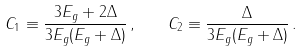<formula> <loc_0><loc_0><loc_500><loc_500>C _ { 1 } \equiv \frac { 3 E _ { g } + 2 \Delta } { 3 E _ { g } ( E _ { g } + \Delta ) } \, , \quad C _ { 2 } \equiv \frac { \Delta } { 3 E _ { g } ( E _ { g } + \Delta ) } \, .</formula> 